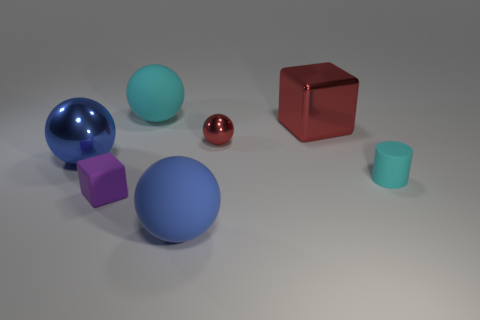Subtract all brown blocks. How many blue balls are left? 2 Subtract all red spheres. How many spheres are left? 3 Subtract all large blue rubber spheres. How many spheres are left? 3 Subtract all gray balls. Subtract all yellow blocks. How many balls are left? 4 Add 2 large cyan shiny spheres. How many objects exist? 9 Subtract 0 yellow cylinders. How many objects are left? 7 Subtract all balls. How many objects are left? 3 Subtract all tiny cyan metal cylinders. Subtract all tiny shiny things. How many objects are left? 6 Add 5 small cyan cylinders. How many small cyan cylinders are left? 6 Add 3 small objects. How many small objects exist? 6 